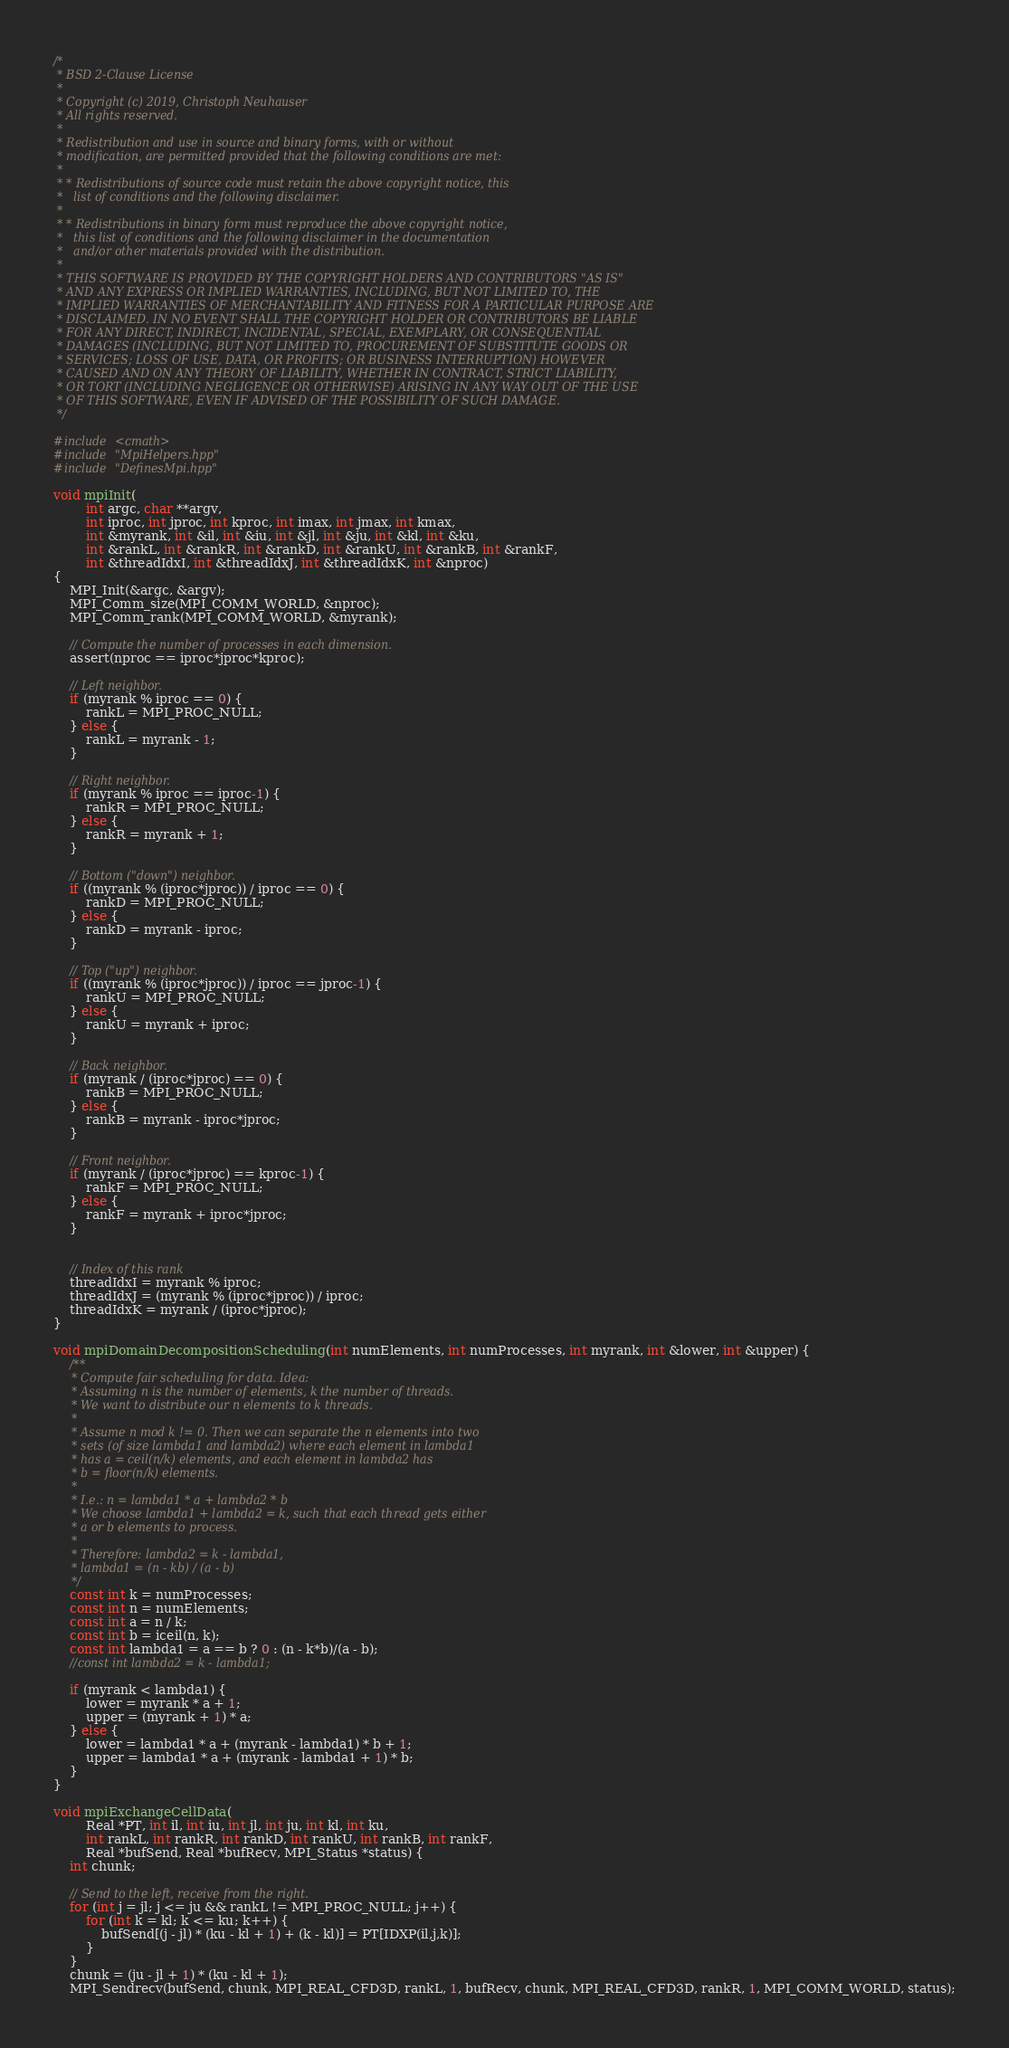Convert code to text. <code><loc_0><loc_0><loc_500><loc_500><_C++_>/*
 * BSD 2-Clause License
 *
 * Copyright (c) 2019, Christoph Neuhauser
 * All rights reserved.
 *
 * Redistribution and use in source and binary forms, with or without
 * modification, are permitted provided that the following conditions are met:
 *
 * * Redistributions of source code must retain the above copyright notice, this
 *   list of conditions and the following disclaimer.
 *
 * * Redistributions in binary form must reproduce the above copyright notice,
 *   this list of conditions and the following disclaimer in the documentation
 *   and/or other materials provided with the distribution.
 *
 * THIS SOFTWARE IS PROVIDED BY THE COPYRIGHT HOLDERS AND CONTRIBUTORS "AS IS"
 * AND ANY EXPRESS OR IMPLIED WARRANTIES, INCLUDING, BUT NOT LIMITED TO, THE
 * IMPLIED WARRANTIES OF MERCHANTABILITY AND FITNESS FOR A PARTICULAR PURPOSE ARE
 * DISCLAIMED. IN NO EVENT SHALL THE COPYRIGHT HOLDER OR CONTRIBUTORS BE LIABLE
 * FOR ANY DIRECT, INDIRECT, INCIDENTAL, SPECIAL, EXEMPLARY, OR CONSEQUENTIAL
 * DAMAGES (INCLUDING, BUT NOT LIMITED TO, PROCUREMENT OF SUBSTITUTE GOODS OR
 * SERVICES; LOSS OF USE, DATA, OR PROFITS; OR BUSINESS INTERRUPTION) HOWEVER
 * CAUSED AND ON ANY THEORY OF LIABILITY, WHETHER IN CONTRACT, STRICT LIABILITY,
 * OR TORT (INCLUDING NEGLIGENCE OR OTHERWISE) ARISING IN ANY WAY OUT OF THE USE
 * OF THIS SOFTWARE, EVEN IF ADVISED OF THE POSSIBILITY OF SUCH DAMAGE.
 */

#include <cmath>
#include "MpiHelpers.hpp"
#include "DefinesMpi.hpp"

void mpiInit(
        int argc, char **argv,
        int iproc, int jproc, int kproc, int imax, int jmax, int kmax,
        int &myrank, int &il, int &iu, int &jl, int &ju, int &kl, int &ku,
        int &rankL, int &rankR, int &rankD, int &rankU, int &rankB, int &rankF,
        int &threadIdxI, int &threadIdxJ, int &threadIdxK, int &nproc)
{
    MPI_Init(&argc, &argv);
    MPI_Comm_size(MPI_COMM_WORLD, &nproc);
    MPI_Comm_rank(MPI_COMM_WORLD, &myrank);

    // Compute the number of processes in each dimension.
    assert(nproc == iproc*jproc*kproc);

    // Left neighbor.
    if (myrank % iproc == 0) {
        rankL = MPI_PROC_NULL;
    } else {
        rankL = myrank - 1;
    }

    // Right neighbor.
    if (myrank % iproc == iproc-1) {
        rankR = MPI_PROC_NULL;
    } else {
        rankR = myrank + 1;
    }

    // Bottom ("down") neighbor.
    if ((myrank % (iproc*jproc)) / iproc == 0) {
        rankD = MPI_PROC_NULL;
    } else {
        rankD = myrank - iproc;
    }

    // Top ("up") neighbor.
    if ((myrank % (iproc*jproc)) / iproc == jproc-1) {
        rankU = MPI_PROC_NULL;
    } else {
        rankU = myrank + iproc;
    }

    // Back neighbor.
    if (myrank / (iproc*jproc) == 0) {
        rankB = MPI_PROC_NULL;
    } else {
        rankB = myrank - iproc*jproc;
    }

    // Front neighbor.
    if (myrank / (iproc*jproc) == kproc-1) {
        rankF = MPI_PROC_NULL;
    } else {
        rankF = myrank + iproc*jproc;
    }


    // Index of this rank
    threadIdxI = myrank % iproc;
    threadIdxJ = (myrank % (iproc*jproc)) / iproc;
    threadIdxK = myrank / (iproc*jproc);
}

void mpiDomainDecompositionScheduling(int numElements, int numProcesses, int myrank, int &lower, int &upper) {
    /**
     * Compute fair scheduling for data. Idea:
     * Assuming n is the number of elements, k the number of threads.
     * We want to distribute our n elements to k threads.
     *
     * Assume n mod k != 0. Then we can separate the n elements into two
     * sets (of size lambda1 and lambda2) where each element in lambda1
     * has a = ceil(n/k) elements, and each element in lambda2 has
     * b = floor(n/k) elements.
     *
     * I.e.: n = lambda1 * a + lambda2 * b
     * We choose lambda1 + lambda2 = k, such that each thread gets either
     * a or b elements to process.
     *
     * Therefore: lambda2 = k - lambda1,
     * lambda1 = (n - kb) / (a - b)
     */
    const int k = numProcesses;
    const int n = numElements;
    const int a = n / k;
    const int b = iceil(n, k);
    const int lambda1 = a == b ? 0 : (n - k*b)/(a - b);
    //const int lambda2 = k - lambda1;

    if (myrank < lambda1) {
        lower = myrank * a + 1;
        upper = (myrank + 1) * a;
    } else {
        lower = lambda1 * a + (myrank - lambda1) * b + 1;
        upper = lambda1 * a + (myrank - lambda1 + 1) * b;
    }
}

void mpiExchangeCellData(
        Real *PT, int il, int iu, int jl, int ju, int kl, int ku,
        int rankL, int rankR, int rankD, int rankU, int rankB, int rankF,
        Real *bufSend, Real *bufRecv, MPI_Status *status) {
    int chunk;

    // Send to the left, receive from the right.
    for (int j = jl; j <= ju && rankL != MPI_PROC_NULL; j++) {
        for (int k = kl; k <= ku; k++) {
            bufSend[(j - jl) * (ku - kl + 1) + (k - kl)] = PT[IDXP(il,j,k)];
        }
    }
    chunk = (ju - jl + 1) * (ku - kl + 1);
    MPI_Sendrecv(bufSend, chunk, MPI_REAL_CFD3D, rankL, 1, bufRecv, chunk, MPI_REAL_CFD3D, rankR, 1, MPI_COMM_WORLD, status);</code> 